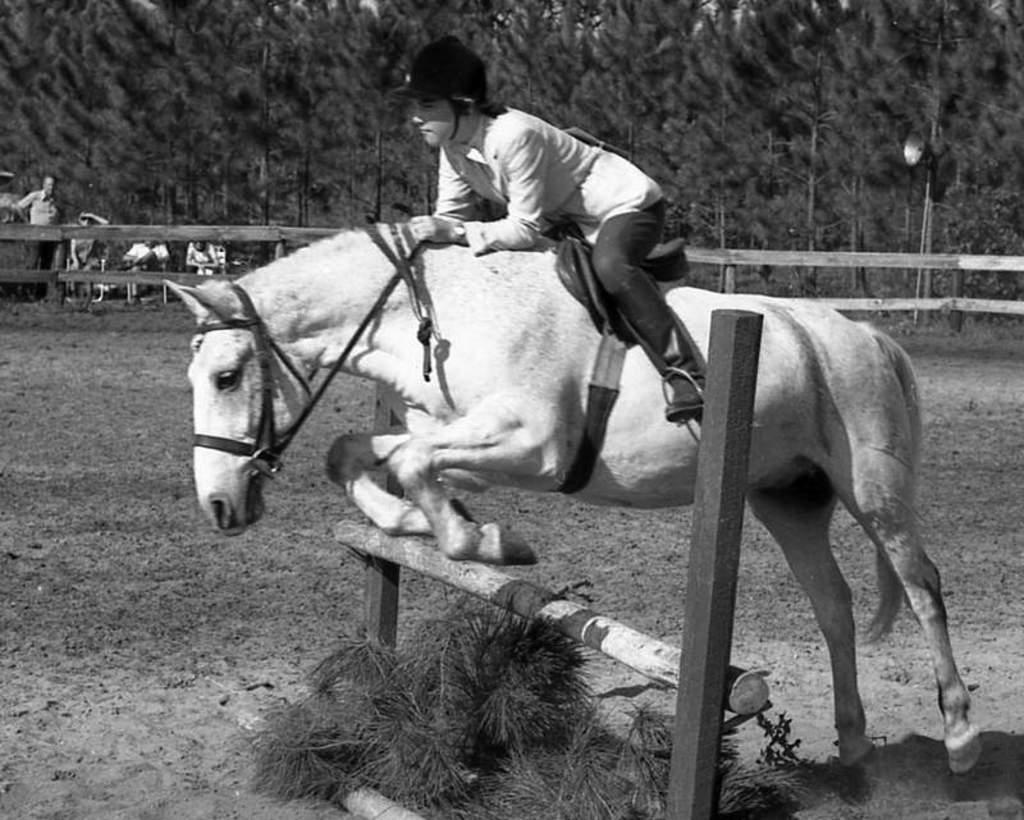In one or two sentences, can you explain what this image depicts? The picture is taken in a ground. A person is riding a horse. The horse is jumping a hurdle. There are fence around the ground. In the background there are trees and few persons. They are watching the man riding the horse. 